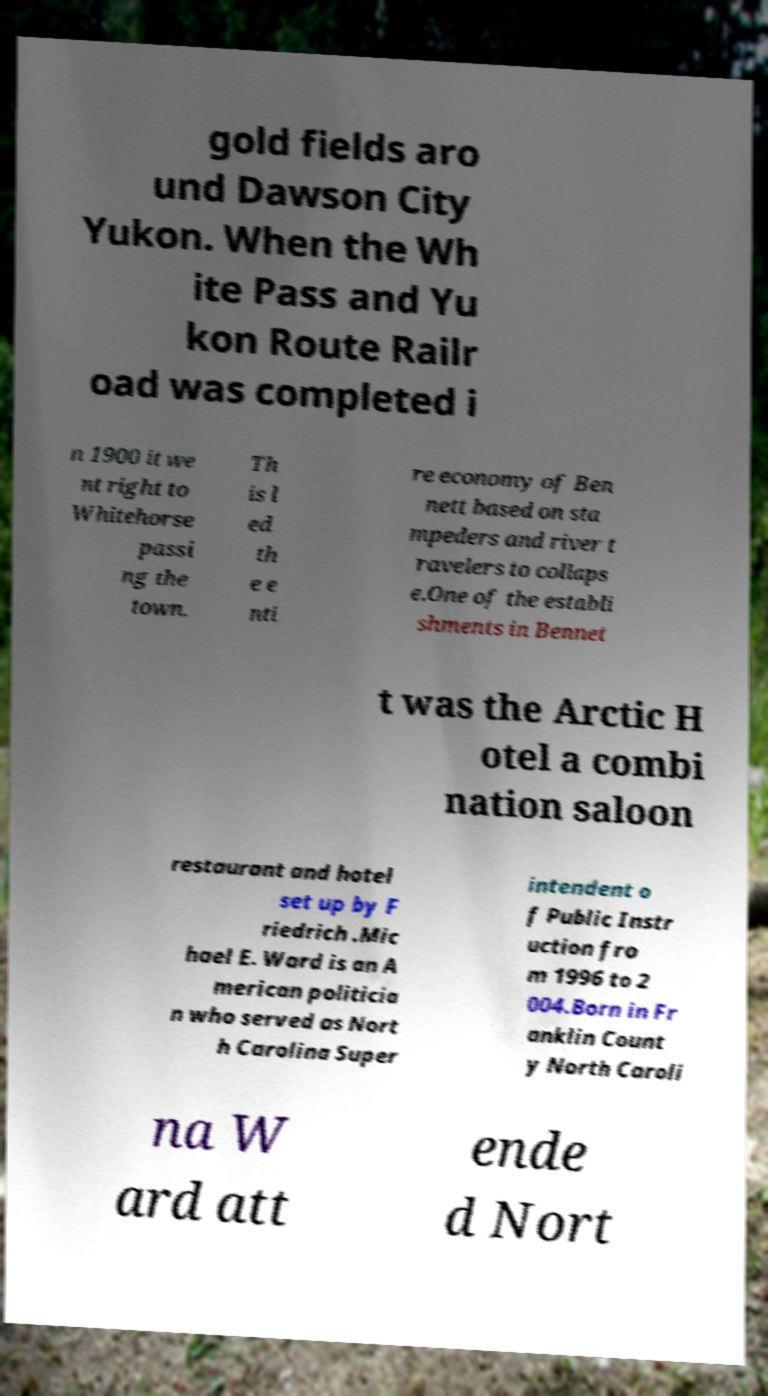I need the written content from this picture converted into text. Can you do that? gold fields aro und Dawson City Yukon. When the Wh ite Pass and Yu kon Route Railr oad was completed i n 1900 it we nt right to Whitehorse passi ng the town. Th is l ed th e e nti re economy of Ben nett based on sta mpeders and river t ravelers to collaps e.One of the establi shments in Bennet t was the Arctic H otel a combi nation saloon restaurant and hotel set up by F riedrich .Mic hael E. Ward is an A merican politicia n who served as Nort h Carolina Super intendent o f Public Instr uction fro m 1996 to 2 004.Born in Fr anklin Count y North Caroli na W ard att ende d Nort 